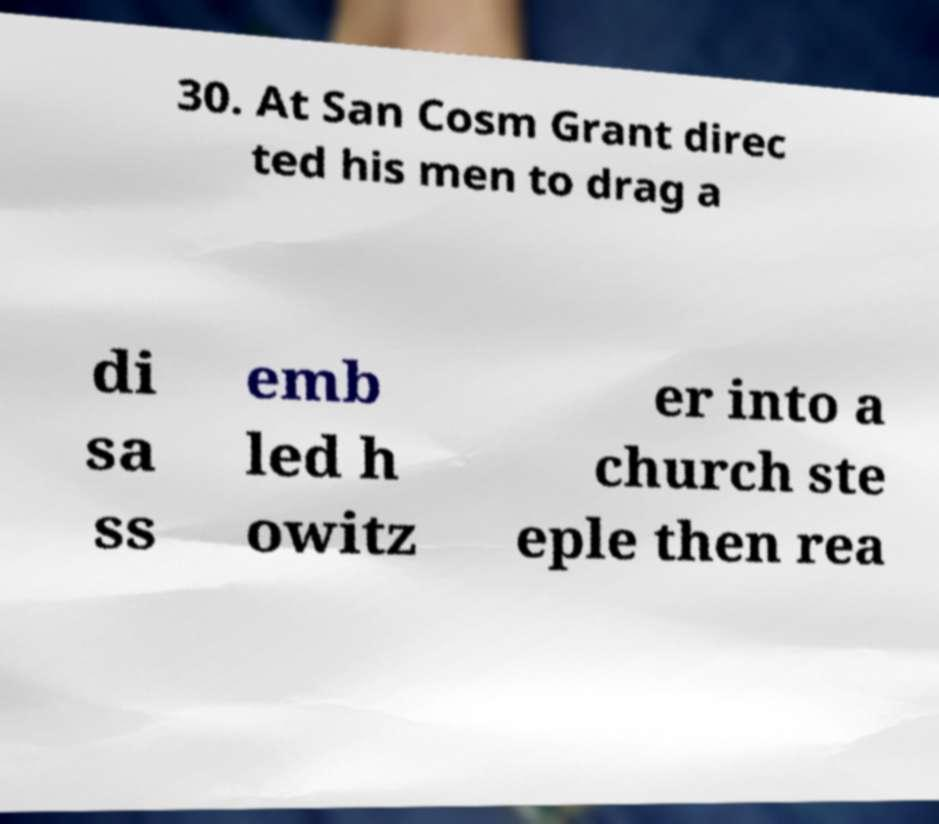Can you accurately transcribe the text from the provided image for me? 30. At San Cosm Grant direc ted his men to drag a di sa ss emb led h owitz er into a church ste eple then rea 